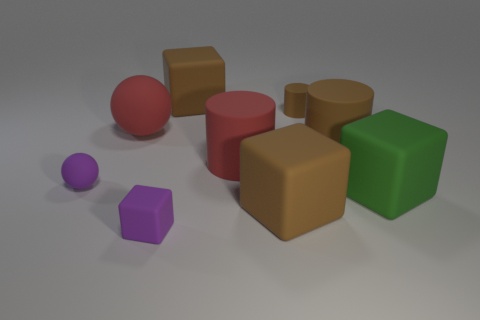How many small cubes have the same material as the purple sphere?
Provide a short and direct response. 1. There is a small block that is the same material as the large sphere; what color is it?
Give a very brief answer. Purple. There is a large red thing on the left side of the large red thing that is right of the big brown matte block behind the tiny cylinder; what is its material?
Provide a short and direct response. Rubber. Is the size of the brown matte cube behind the green object the same as the large red rubber cylinder?
Make the answer very short. Yes. How many big objects are either matte cubes or cylinders?
Offer a very short reply. 5. Is there a small object of the same color as the tiny ball?
Offer a very short reply. Yes. There is a green thing that is the same size as the red ball; what shape is it?
Your response must be concise. Cube. There is a tiny thing that is to the left of the tiny purple rubber block; is its color the same as the tiny rubber block?
Offer a terse response. Yes. How many things are small rubber objects on the left side of the tiny purple cube or tiny cylinders?
Make the answer very short. 2. Are there more big cylinders that are on the left side of the large green thing than green cubes that are behind the tiny brown object?
Your answer should be very brief. Yes. 